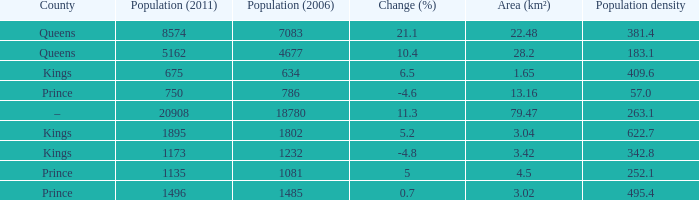In the County of Prince, what was the highest Population density when the Area (km²) was larger than 3.02, and the Population (2006) was larger than 786, and the Population (2011) was smaller than 1135? None. 